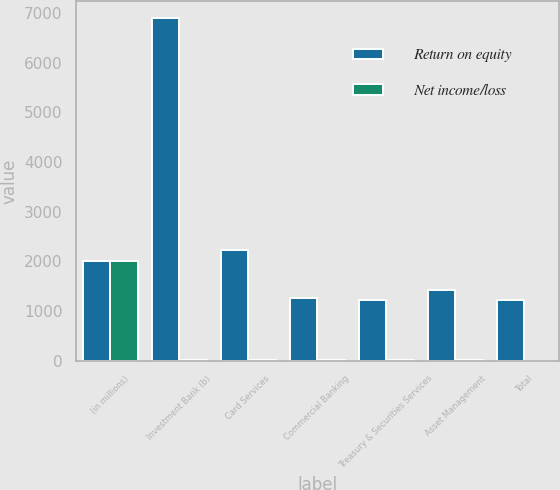Convert chart. <chart><loc_0><loc_0><loc_500><loc_500><stacked_bar_chart><ecel><fcel>(in millions)<fcel>Investment Bank (b)<fcel>Card Services<fcel>Commercial Banking<fcel>Treasury & Securities Services<fcel>Asset Management<fcel>Total<nl><fcel>Return on equity<fcel>2009<fcel>6899<fcel>2225<fcel>1271<fcel>1226<fcel>1430<fcel>1226<nl><fcel>Net income/loss<fcel>2009<fcel>21<fcel>15<fcel>16<fcel>25<fcel>20<fcel>6<nl></chart> 